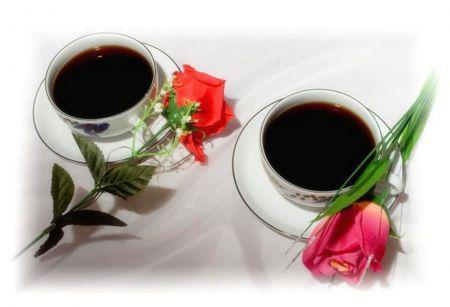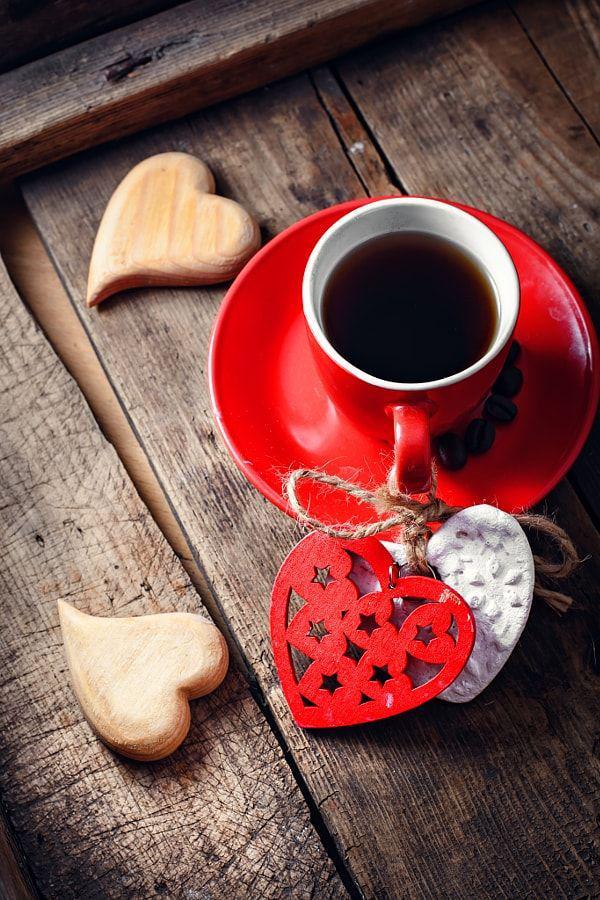The first image is the image on the left, the second image is the image on the right. Considering the images on both sides, is "there is coffee in sold white cups on a eooden table" valid? Answer yes or no. No. 